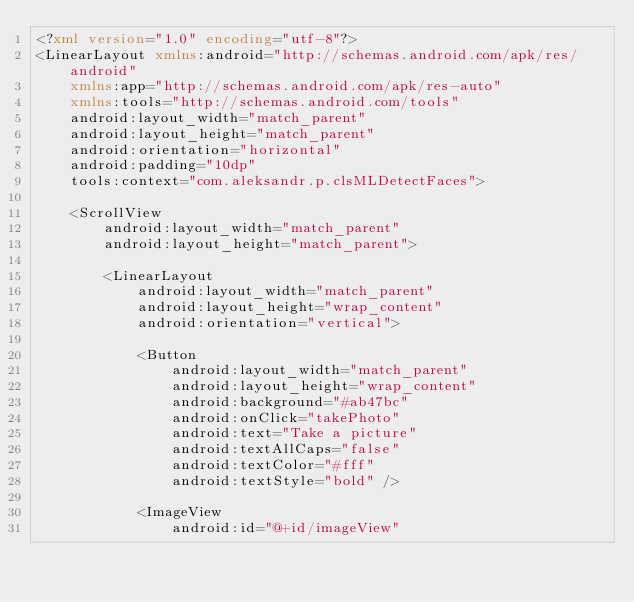<code> <loc_0><loc_0><loc_500><loc_500><_XML_><?xml version="1.0" encoding="utf-8"?>
<LinearLayout xmlns:android="http://schemas.android.com/apk/res/android"
    xmlns:app="http://schemas.android.com/apk/res-auto"
    xmlns:tools="http://schemas.android.com/tools"
    android:layout_width="match_parent"
    android:layout_height="match_parent"
    android:orientation="horizontal"
    android:padding="10dp"
    tools:context="com.aleksandr.p.clsMLDetectFaces">

    <ScrollView
        android:layout_width="match_parent"
        android:layout_height="match_parent">

        <LinearLayout
            android:layout_width="match_parent"
            android:layout_height="wrap_content"
            android:orientation="vertical">

            <Button
                android:layout_width="match_parent"
                android:layout_height="wrap_content"
                android:background="#ab47bc"
                android:onClick="takePhoto"
                android:text="Take a picture"
                android:textAllCaps="false"
                android:textColor="#fff"
                android:textStyle="bold" />

            <ImageView
                android:id="@+id/imageView"</code> 